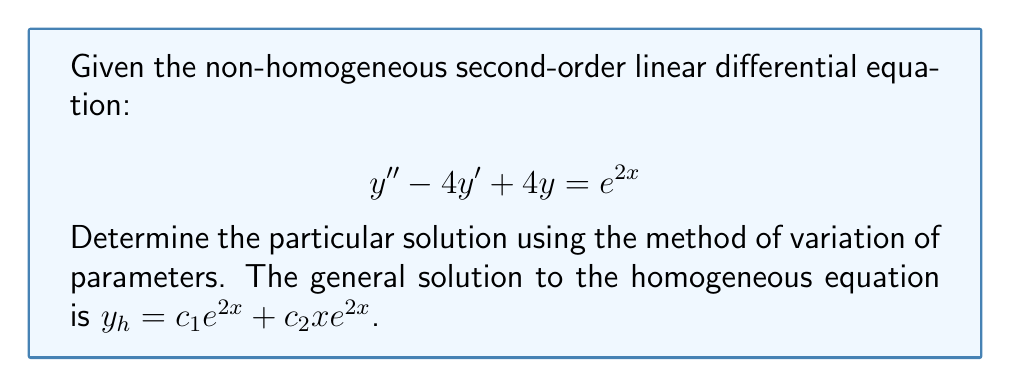Can you solve this math problem? Let's solve this step-by-step:

1) We have the general solution to the homogeneous equation:
   $y_h = c_1e^{2x} + c_2xe^{2x}$

2) For variation of parameters, we assume a particular solution of the form:
   $y_p = u_1e^{2x} + u_2xe^{2x}$

3) We need to find $u_1$ and $u_2$. They must satisfy:
   $$\begin{align}
   u_1'e^{2x} + u_2'xe^{2x} &= 0 \\
   u_1'(2e^{2x}) + u_2'(e^{2x} + 2xe^{2x}) &= e^{2x}
   \end{align}$$

4) Solving this system of equations:
   $$\begin{align}
   u_1' &= -\frac{x}{2} \\
   u_2' &= \frac{1}{2}
   \end{align}$$

5) Integrating to find $u_1$ and $u_2$:
   $$\begin{align}
   u_1 &= -\int \frac{x}{2} dx = -\frac{x^2}{4} + C_1 \\
   u_2 &= \int \frac{1}{2} dx = \frac{x}{2} + C_2
   \end{align}$$

6) The particular solution is:
   $$y_p = (-\frac{x^2}{4} + C_1)e^{2x} + (\frac{x}{2} + C_2)xe^{2x}$$

7) Simplify and combine like terms:
   $$y_p = -\frac{x^2}{4}e^{2x} + \frac{x^2}{2}e^{2x} + (C_1 + C_2x)e^{2x}$$

8) The last term $(C_1 + C_2x)e^{2x}$ is a solution to the homogeneous equation, so we can set $C_1 = C_2 = 0$ for the particular solution.

9) Therefore, the final particular solution is:
   $$y_p = \frac{x^2}{4}e^{2x}$$
Answer: $y_p = \frac{x^2}{4}e^{2x}$ 